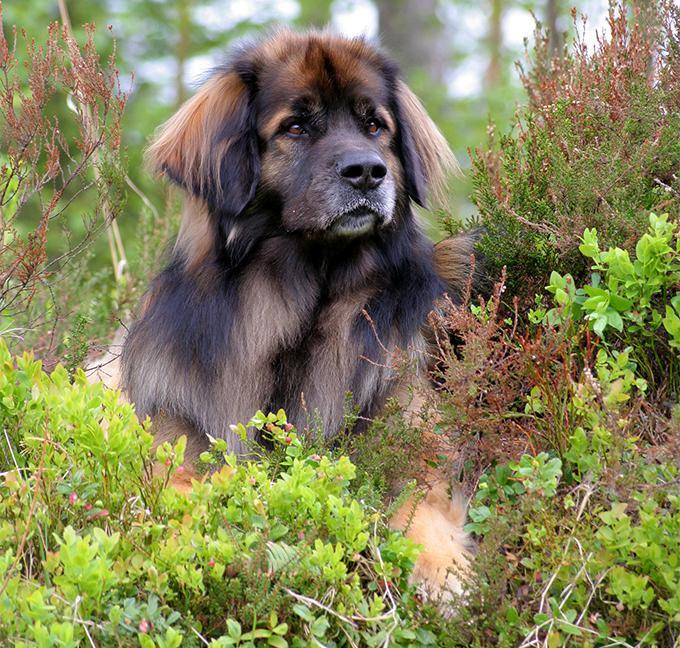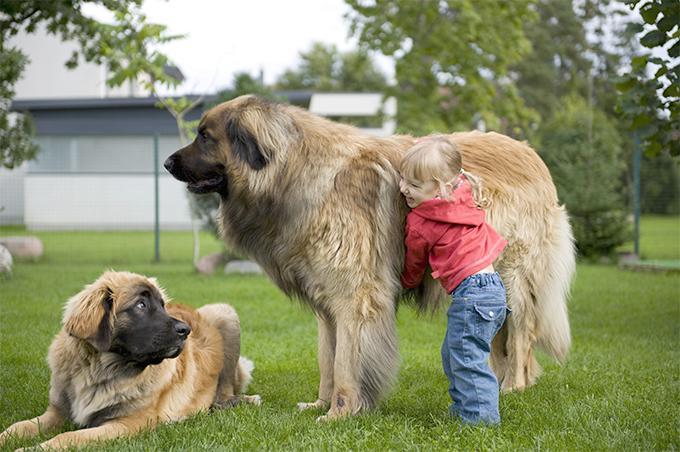The first image is the image on the left, the second image is the image on the right. Considering the images on both sides, is "Right and left images contain the same number of dogs." valid? Answer yes or no. No. The first image is the image on the left, the second image is the image on the right. Given the left and right images, does the statement "There are no more than three dogs" hold true? Answer yes or no. Yes. 